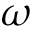Convert formula to latex. <formula><loc_0><loc_0><loc_500><loc_500>\omega</formula> 